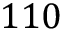<formula> <loc_0><loc_0><loc_500><loc_500>1 1 0</formula> 